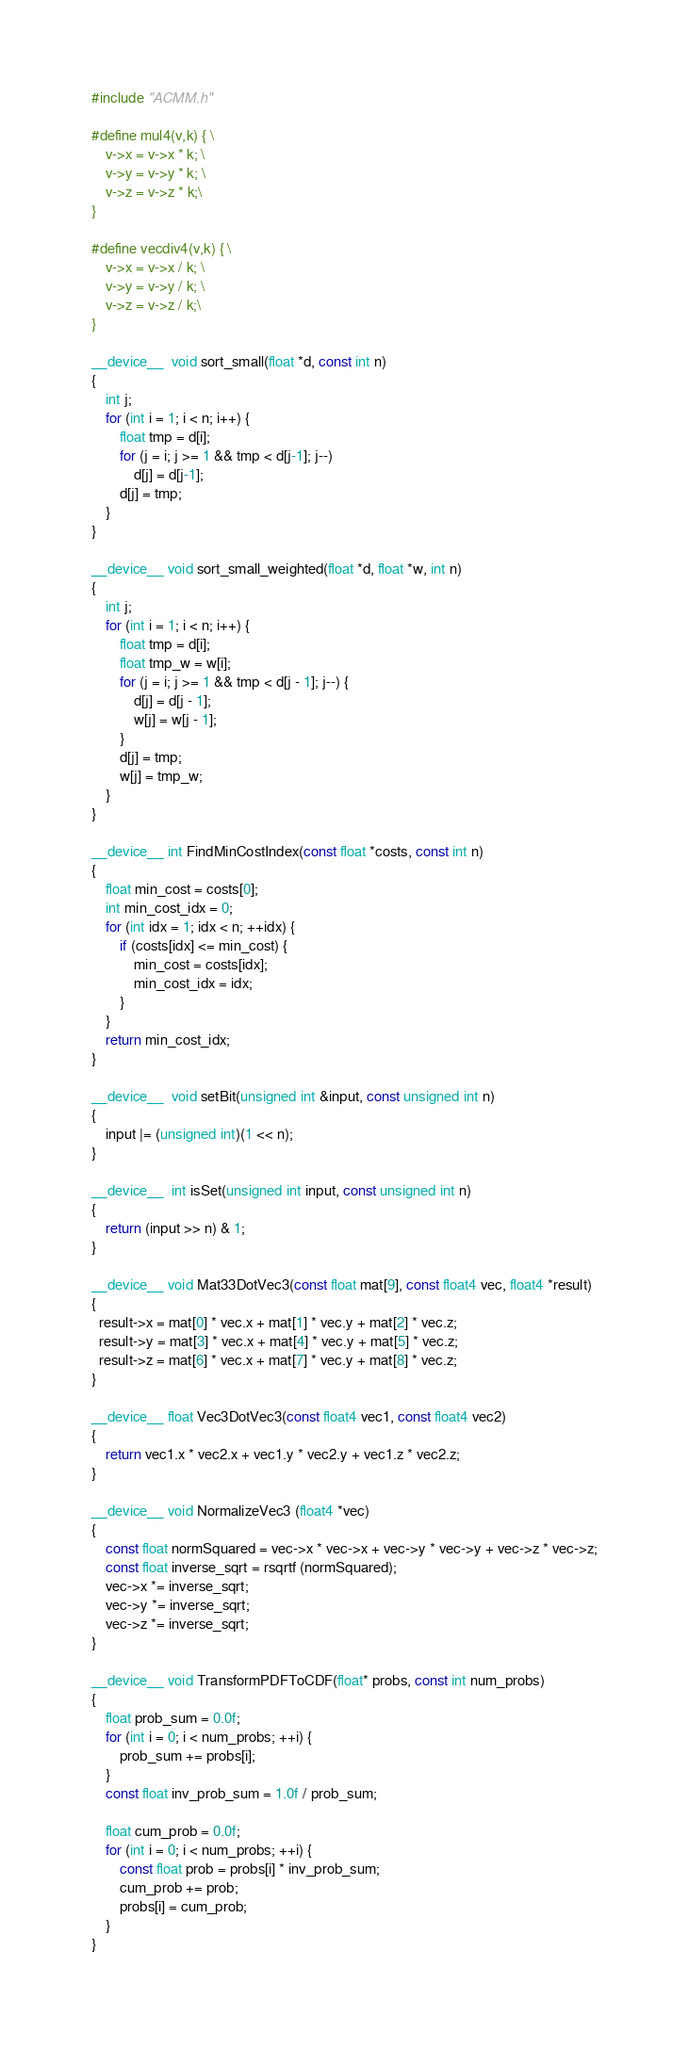Convert code to text. <code><loc_0><loc_0><loc_500><loc_500><_Cuda_>#include "ACMM.h"

#define mul4(v,k) { \
    v->x = v->x * k; \
    v->y = v->y * k; \
    v->z = v->z * k;\
}

#define vecdiv4(v,k) { \
    v->x = v->x / k; \
    v->y = v->y / k; \
    v->z = v->z / k;\
}

__device__  void sort_small(float *d, const int n)
{
    int j;
    for (int i = 1; i < n; i++) {
        float tmp = d[i];
        for (j = i; j >= 1 && tmp < d[j-1]; j--)
            d[j] = d[j-1];
        d[j] = tmp;
    }
}

__device__ void sort_small_weighted(float *d, float *w, int n)
{
    int j;
    for (int i = 1; i < n; i++) {
        float tmp = d[i];
        float tmp_w = w[i];
        for (j = i; j >= 1 && tmp < d[j - 1]; j--) {
            d[j] = d[j - 1];
            w[j] = w[j - 1];
        }
        d[j] = tmp;
        w[j] = tmp_w;
    }
}

__device__ int FindMinCostIndex(const float *costs, const int n)
{
    float min_cost = costs[0];
    int min_cost_idx = 0;
    for (int idx = 1; idx < n; ++idx) {
        if (costs[idx] <= min_cost) {
            min_cost = costs[idx];
            min_cost_idx = idx;
        }
    }
    return min_cost_idx;
}

__device__  void setBit(unsigned int &input, const unsigned int n)
{
    input |= (unsigned int)(1 << n);
}

__device__  int isSet(unsigned int input, const unsigned int n)
{
    return (input >> n) & 1;
}

__device__ void Mat33DotVec3(const float mat[9], const float4 vec, float4 *result)
{
  result->x = mat[0] * vec.x + mat[1] * vec.y + mat[2] * vec.z;
  result->y = mat[3] * vec.x + mat[4] * vec.y + mat[5] * vec.z;
  result->z = mat[6] * vec.x + mat[7] * vec.y + mat[8] * vec.z;
}

__device__ float Vec3DotVec3(const float4 vec1, const float4 vec2)
{
    return vec1.x * vec2.x + vec1.y * vec2.y + vec1.z * vec2.z;
}

__device__ void NormalizeVec3 (float4 *vec)
{
    const float normSquared = vec->x * vec->x + vec->y * vec->y + vec->z * vec->z;
    const float inverse_sqrt = rsqrtf (normSquared);
    vec->x *= inverse_sqrt;
    vec->y *= inverse_sqrt;
    vec->z *= inverse_sqrt;
}

__device__ void TransformPDFToCDF(float* probs, const int num_probs)
{
    float prob_sum = 0.0f;
    for (int i = 0; i < num_probs; ++i) {
        prob_sum += probs[i];
    }
    const float inv_prob_sum = 1.0f / prob_sum;

    float cum_prob = 0.0f;
    for (int i = 0; i < num_probs; ++i) {
        const float prob = probs[i] * inv_prob_sum;
        cum_prob += prob;
        probs[i] = cum_prob;
    }
}
</code> 